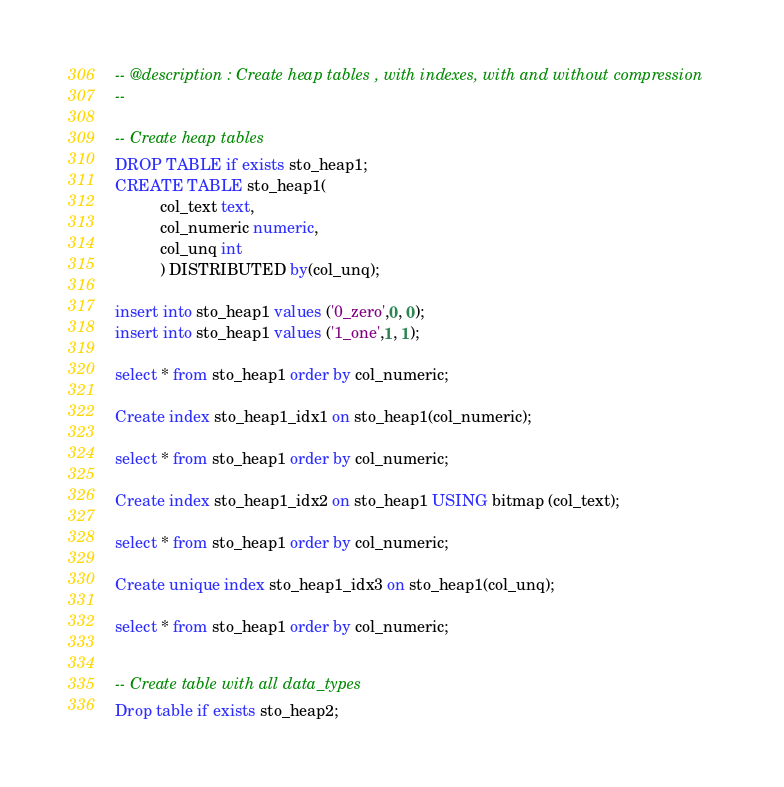<code> <loc_0><loc_0><loc_500><loc_500><_SQL_>-- @description : Create heap tables , with indexes, with and without compression
-- 

-- Create heap tables 
DROP TABLE if exists sto_heap1;
CREATE TABLE sto_heap1(
          col_text text,
          col_numeric numeric,
          col_unq int
          ) DISTRIBUTED by(col_unq);

insert into sto_heap1 values ('0_zero',0, 0);
insert into sto_heap1 values ('1_one',1, 1);

select * from sto_heap1 order by col_numeric;

Create index sto_heap1_idx1 on sto_heap1(col_numeric);

select * from sto_heap1 order by col_numeric;

Create index sto_heap1_idx2 on sto_heap1 USING bitmap (col_text);

select * from sto_heap1 order by col_numeric;

Create unique index sto_heap1_idx3 on sto_heap1(col_unq);

select * from sto_heap1 order by col_numeric;


-- Create table with all data_types 
Drop table if exists sto_heap2;</code> 